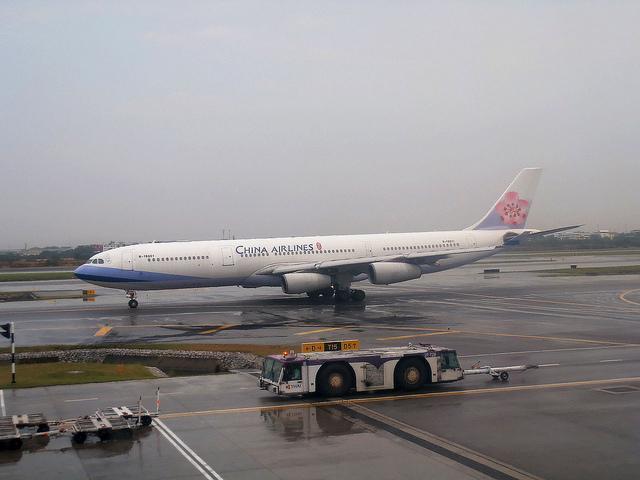How many knives are shown in the picture?
Give a very brief answer. 0. 